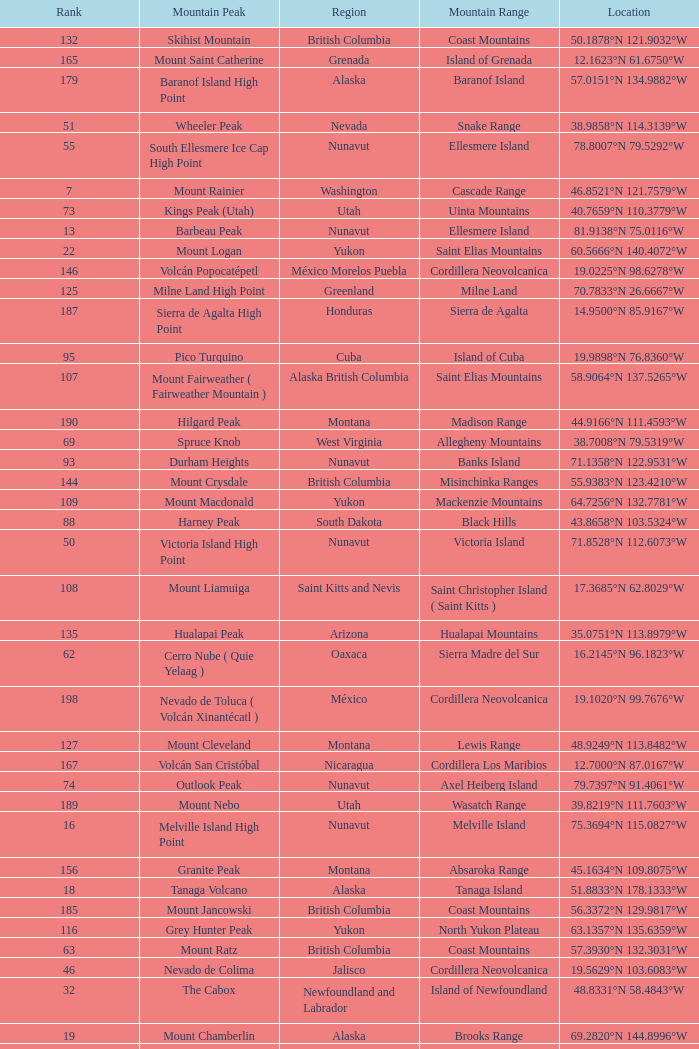Which Mountain Peak has a Region of baja california, and a Location of 28.1301°n 115.2206°w? Isla Cedros High Point. 